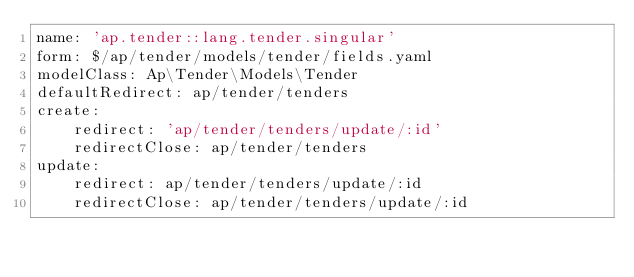Convert code to text. <code><loc_0><loc_0><loc_500><loc_500><_YAML_>name: 'ap.tender::lang.tender.singular'
form: $/ap/tender/models/tender/fields.yaml
modelClass: Ap\Tender\Models\Tender
defaultRedirect: ap/tender/tenders
create:
    redirect: 'ap/tender/tenders/update/:id'
    redirectClose: ap/tender/tenders
update:
    redirect: ap/tender/tenders/update/:id
    redirectClose: ap/tender/tenders/update/:id</code> 